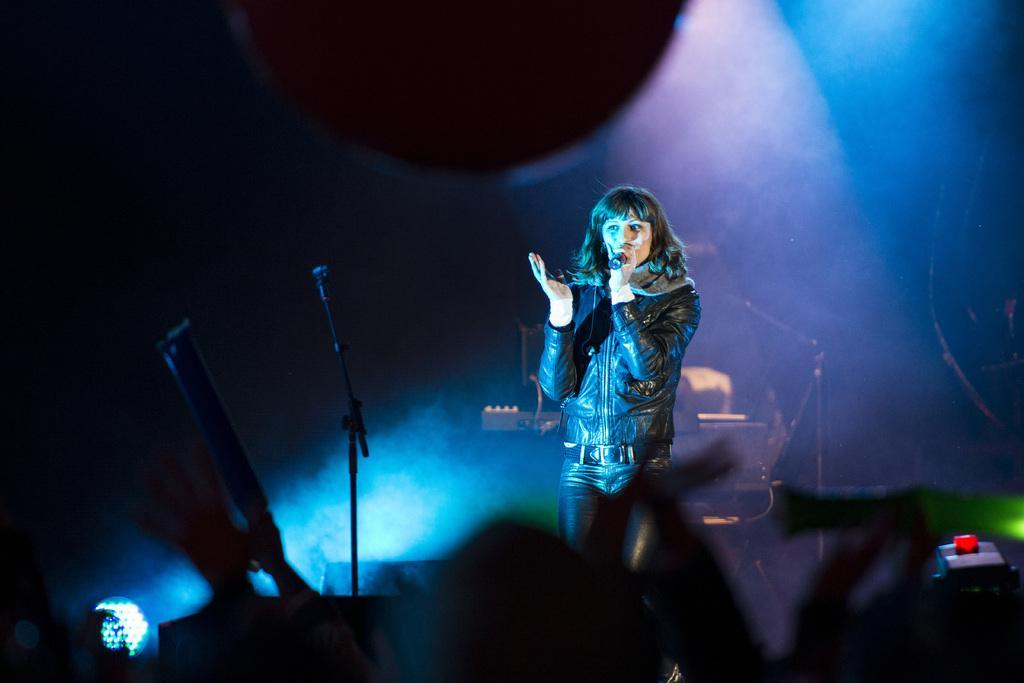How would you summarize this image in a sentence or two? In this image I can see the person wearing the dress and holding the mic. To the side of the person I can see an another mic, musical instrument and an object. And there is a blue, purple and black background. 